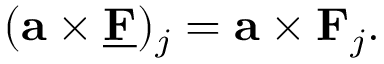<formula> <loc_0><loc_0><loc_500><loc_500>( \mathbf a \times \underline { \mathbf F } ) _ { j } = \mathbf a \times \mathbf F _ { j } .</formula> 